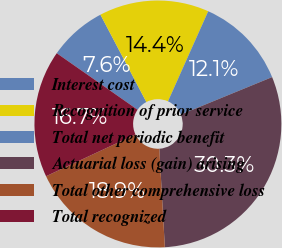Convert chart. <chart><loc_0><loc_0><loc_500><loc_500><pie_chart><fcel>Interest cost<fcel>Recognition of prior service<fcel>Total net periodic benefit<fcel>Actuarial loss (gain) arising<fcel>Total other comprehensive loss<fcel>Total recognized<nl><fcel>7.58%<fcel>14.39%<fcel>12.12%<fcel>30.3%<fcel>18.94%<fcel>16.67%<nl></chart> 